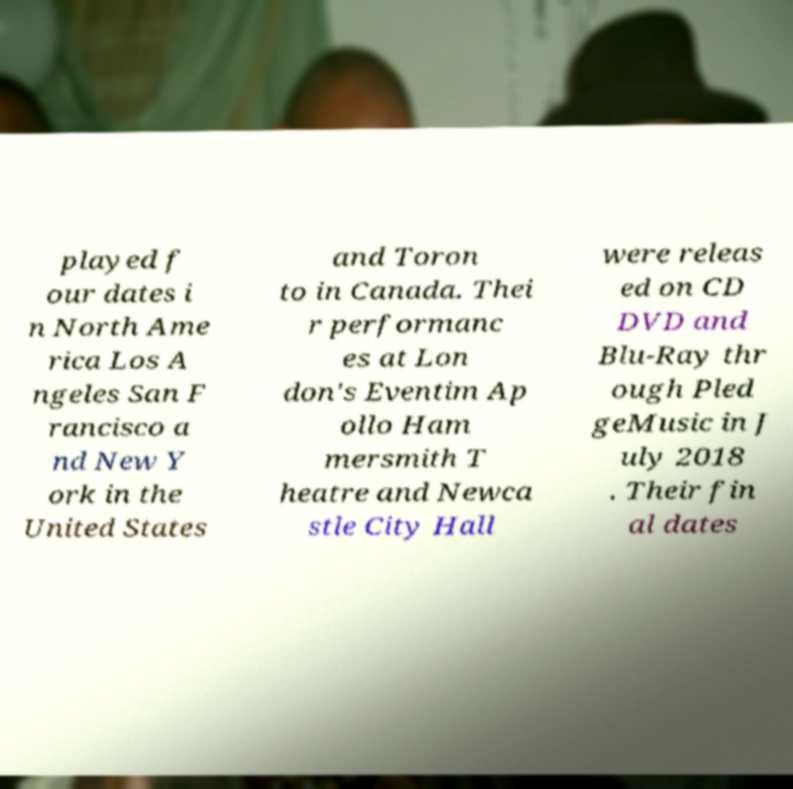Can you accurately transcribe the text from the provided image for me? played f our dates i n North Ame rica Los A ngeles San F rancisco a nd New Y ork in the United States and Toron to in Canada. Thei r performanc es at Lon don's Eventim Ap ollo Ham mersmith T heatre and Newca stle City Hall were releas ed on CD DVD and Blu-Ray thr ough Pled geMusic in J uly 2018 . Their fin al dates 